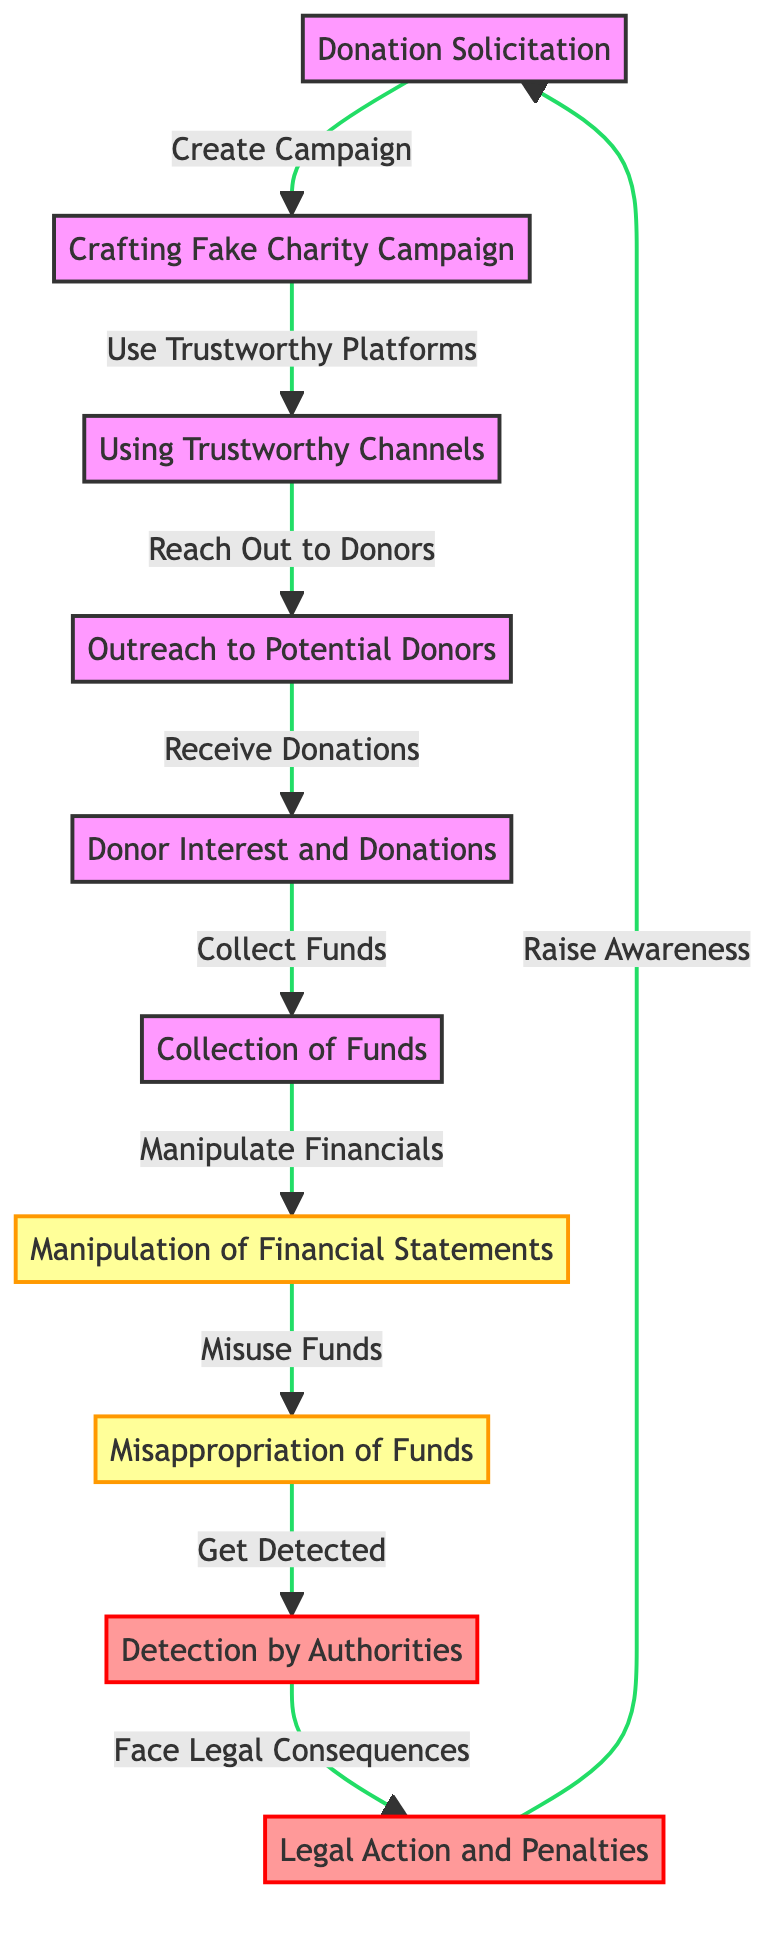What is the first step in the scam process? The first step in the process is "Donation Solicitation." This is stated explicitly in the diagram, indicating that the process begins with soliciting donations.
Answer: Donation Solicitation How many nodes are there in the diagram? The diagram contains a total of 10 nodes. These nodes represent different stages in the fake charity scam process, as listed in the node information.
Answer: 10 Which node collects the funds? The node responsible for collecting the funds is "Collection of Funds." This node appears after "Donor Interest and Donations" and signifies the step where the actual money is collected.
Answer: Collection of Funds What action follows "Manipulation of Financial Statements"? The action that follows "Manipulation of Financial Statements" is "Misappropriation of Funds." The directed edge from node 7 to node 8 indicates that manipulating financial statements leads to misusing the collected funds.
Answer: Misappropriation of Funds What is the outcome of detection by authorities? The outcome of detection by authorities is "Legal Action and Penalties." After the detection, as shown in the diagram, it directs to this final stage, which outlines the consequences faced by the perpetrators.
Answer: Legal Action and Penalties Which two nodes are linked by the label "Use Trustworthy Platforms"? The nodes linked by the label "Use Trustworthy Platforms" are "Crafting Fake Charity Campaign" and "Using Trustworthy Channels." The edge connecting these two nodes shows the process of utilizing trusted platforms to lend credibility to the fake charity.
Answer: Crafting Fake Charity Campaign, Using Trustworthy Channels How does the process flow back to raising awareness? The process flows back to raising awareness through "Raise Awareness" after "Legal Action and Penalties." This cyclical connection signifies that awareness could potentially prevent future scams by educating and informing the public.
Answer: Raise Awareness Which step comes immediately before "Get Detected"? The step that comes immediately before "Get Detected" is "Misappropriation of Funds." This order in the diagram indicates that engaging in fraudulent activities will eventually lead to detection by authorities.
Answer: Misappropriation of Funds What is the relationship between "Outreach to Potential Donors" and "Donor Interest and Donations"? The relationship is that "Outreach to Potential Donors" leads to "Donor Interest and Donations." The directed edge shows that outreach efforts are designed to increase donor engagement and contributions.
Answer: Outreach to Potential Donors leads to Donor Interest and Donations 